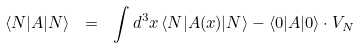Convert formula to latex. <formula><loc_0><loc_0><loc_500><loc_500>\langle N | A | N \rangle \ = \ \int d ^ { 3 } x \, \langle N | A ( x ) | N \rangle - \langle 0 | A | 0 \rangle \cdot V _ { N }</formula> 